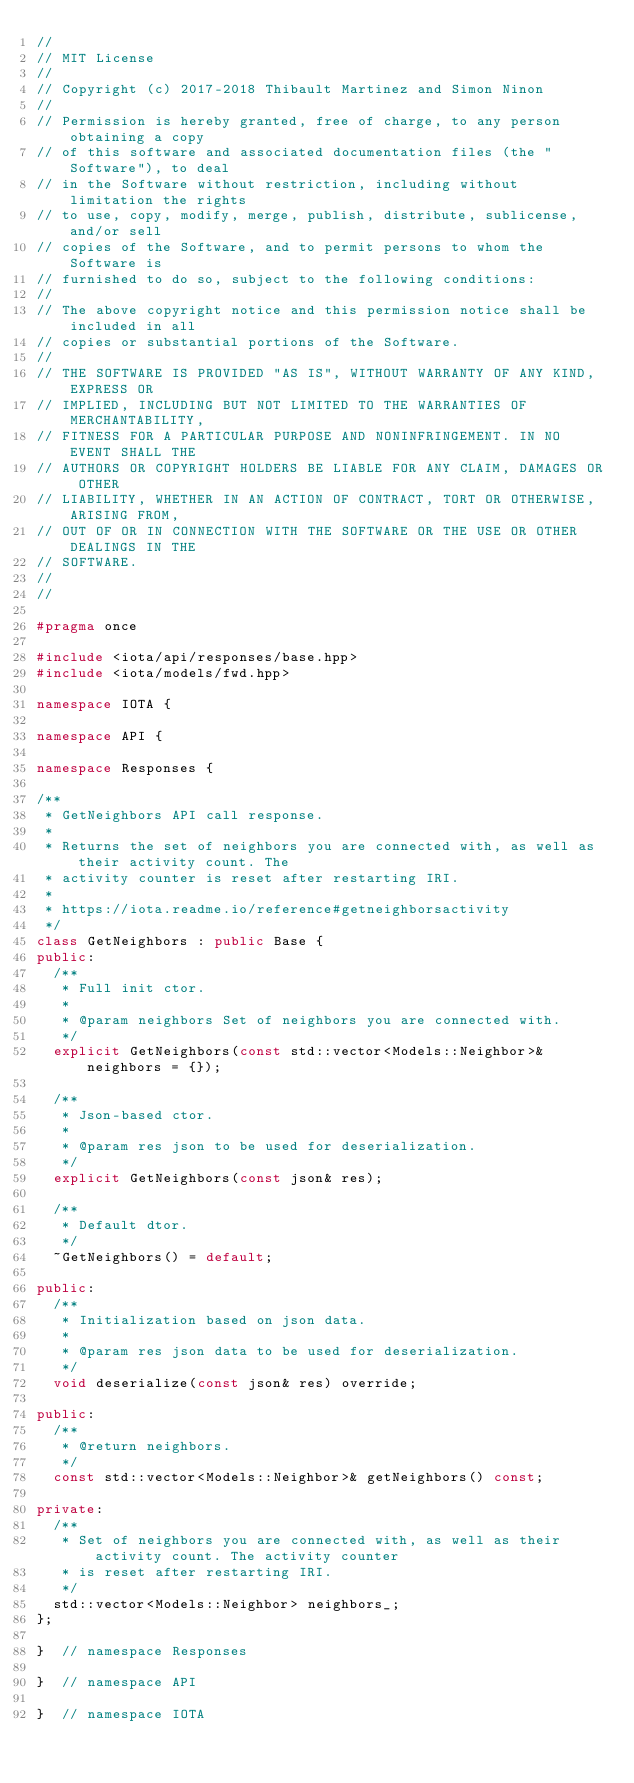<code> <loc_0><loc_0><loc_500><loc_500><_C++_>//
// MIT License
//
// Copyright (c) 2017-2018 Thibault Martinez and Simon Ninon
//
// Permission is hereby granted, free of charge, to any person obtaining a copy
// of this software and associated documentation files (the "Software"), to deal
// in the Software without restriction, including without limitation the rights
// to use, copy, modify, merge, publish, distribute, sublicense, and/or sell
// copies of the Software, and to permit persons to whom the Software is
// furnished to do so, subject to the following conditions:
//
// The above copyright notice and this permission notice shall be included in all
// copies or substantial portions of the Software.
//
// THE SOFTWARE IS PROVIDED "AS IS", WITHOUT WARRANTY OF ANY KIND, EXPRESS OR
// IMPLIED, INCLUDING BUT NOT LIMITED TO THE WARRANTIES OF MERCHANTABILITY,
// FITNESS FOR A PARTICULAR PURPOSE AND NONINFRINGEMENT. IN NO EVENT SHALL THE
// AUTHORS OR COPYRIGHT HOLDERS BE LIABLE FOR ANY CLAIM, DAMAGES OR OTHER
// LIABILITY, WHETHER IN AN ACTION OF CONTRACT, TORT OR OTHERWISE, ARISING FROM,
// OUT OF OR IN CONNECTION WITH THE SOFTWARE OR THE USE OR OTHER DEALINGS IN THE
// SOFTWARE.
//
//

#pragma once

#include <iota/api/responses/base.hpp>
#include <iota/models/fwd.hpp>

namespace IOTA {

namespace API {

namespace Responses {

/**
 * GetNeighbors API call response.
 *
 * Returns the set of neighbors you are connected with, as well as their activity count. The
 * activity counter is reset after restarting IRI.
 *
 * https://iota.readme.io/reference#getneighborsactivity
 */
class GetNeighbors : public Base {
public:
  /**
   * Full init ctor.
   *
   * @param neighbors Set of neighbors you are connected with.
   */
  explicit GetNeighbors(const std::vector<Models::Neighbor>& neighbors = {});

  /**
   * Json-based ctor.
   *
   * @param res json to be used for deserialization.
   */
  explicit GetNeighbors(const json& res);

  /**
   * Default dtor.
   */
  ~GetNeighbors() = default;

public:
  /**
   * Initialization based on json data.
   *
   * @param res json data to be used for deserialization.
   */
  void deserialize(const json& res) override;

public:
  /**
   * @return neighbors.
   */
  const std::vector<Models::Neighbor>& getNeighbors() const;

private:
  /**
   * Set of neighbors you are connected with, as well as their activity count. The activity counter
   * is reset after restarting IRI.
   */
  std::vector<Models::Neighbor> neighbors_;
};

}  // namespace Responses

}  // namespace API

}  // namespace IOTA
</code> 